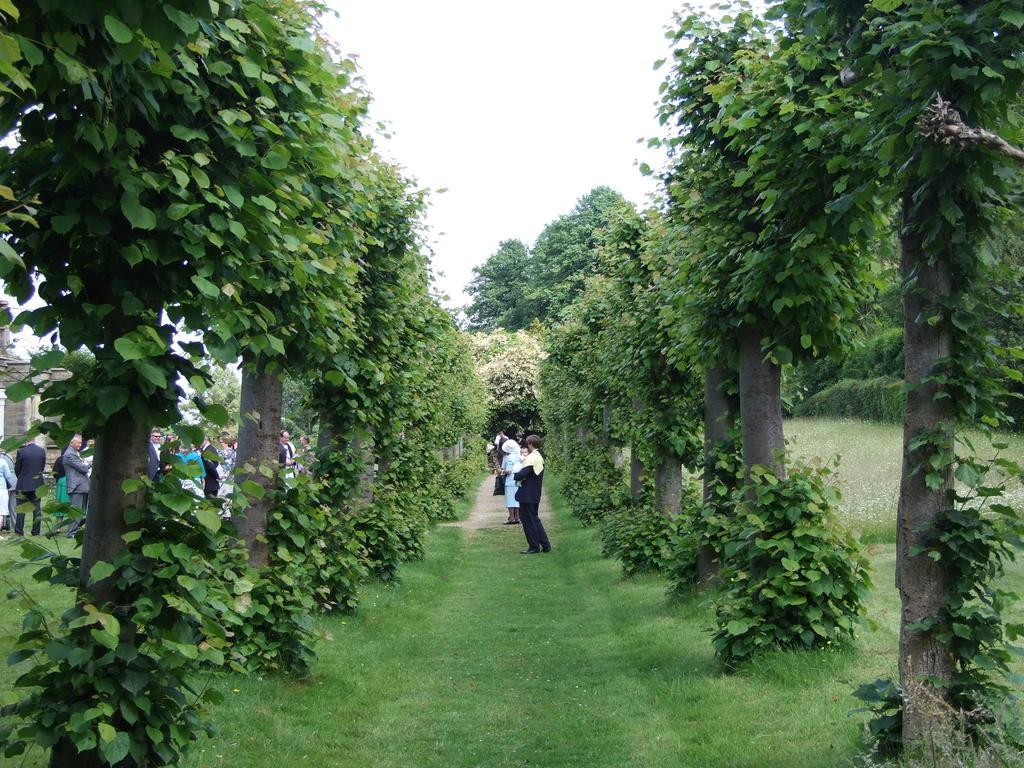In one or two sentences, can you explain what this image depicts? In this image I can see the ground, some grass on the ground, few trees which are green in color and few persons are standing on the ground. In the background I can see few trees and the sky. 